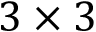Convert formula to latex. <formula><loc_0><loc_0><loc_500><loc_500>3 \times 3</formula> 